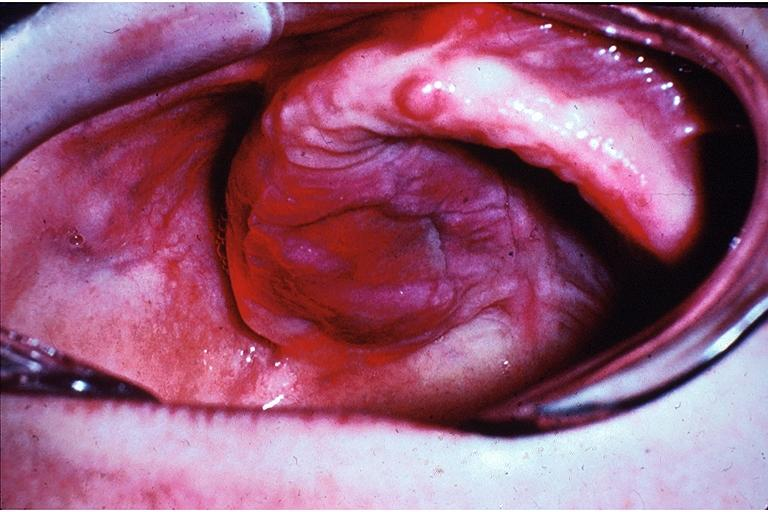does heart show lymphoproliferative disease of the palate?
Answer the question using a single word or phrase. No 